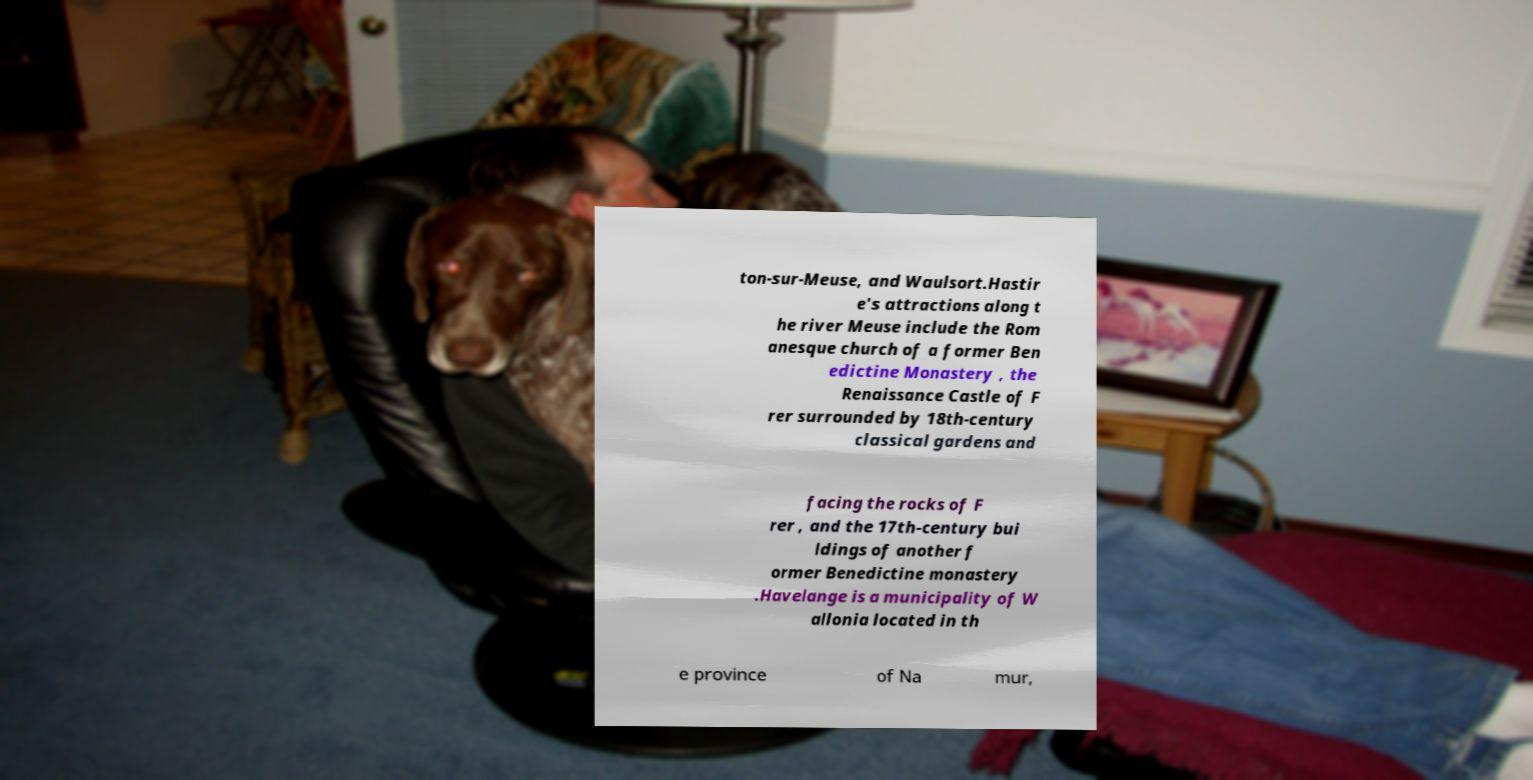Could you assist in decoding the text presented in this image and type it out clearly? ton-sur-Meuse, and Waulsort.Hastir e's attractions along t he river Meuse include the Rom anesque church of a former Ben edictine Monastery , the Renaissance Castle of F rer surrounded by 18th-century classical gardens and facing the rocks of F rer , and the 17th-century bui ldings of another f ormer Benedictine monastery .Havelange is a municipality of W allonia located in th e province of Na mur, 